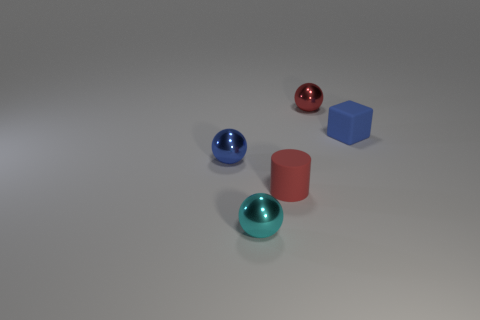There is a matte object right of the red ball; are there any blue matte cubes that are in front of it?
Give a very brief answer. No. How many blocks are small blue matte things or cyan things?
Provide a succinct answer. 1. There is a shiny object that is right of the red thing that is in front of the tiny shiny object behind the tiny cube; what is its size?
Your answer should be very brief. Small. There is a cyan sphere; are there any tiny spheres behind it?
Provide a succinct answer. Yes. There is a metal object that is the same color as the tiny rubber cylinder; what is its shape?
Provide a short and direct response. Sphere. What number of things are either balls that are to the left of the cyan thing or tiny purple balls?
Your response must be concise. 1. What is the size of the cyan sphere that is the same material as the red ball?
Offer a very short reply. Small. There is a red shiny ball; is it the same size as the blue object to the left of the red sphere?
Your answer should be very brief. Yes. There is a small thing that is on the left side of the tiny rubber cube and to the right of the tiny red cylinder; what is its color?
Your answer should be very brief. Red. How many objects are either metal objects that are behind the tiny cyan metallic sphere or tiny objects behind the small cyan thing?
Ensure brevity in your answer.  4. 